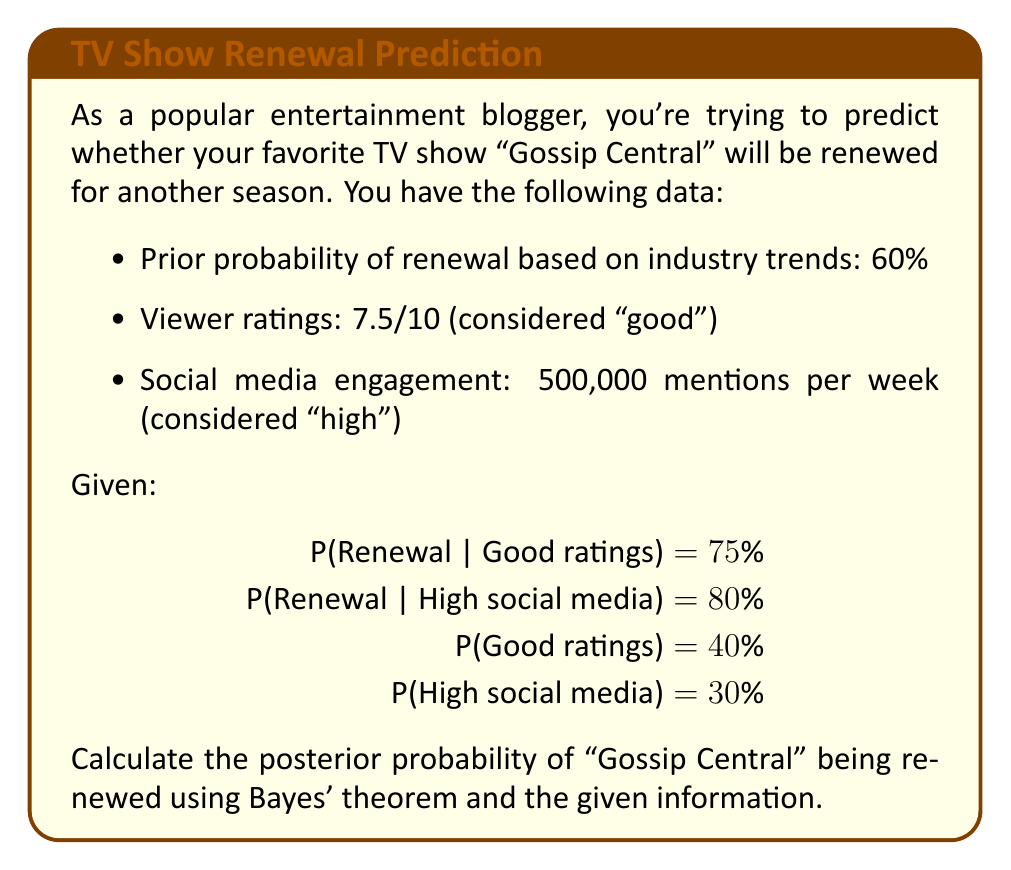Give your solution to this math problem. Let's approach this step-by-step using Bayes' theorem:

1) Define events:
   R: Show is renewed
   G: Good ratings
   S: High social media engagement

2) Given information:
   P(R) = 0.60 (prior probability)
   P(G|R) = 0.75
   P(S|R) = 0.80
   P(G) = 0.40
   P(S) = 0.30

3) We need to calculate P(R|G,S) using Bayes' theorem:

   $$P(R|G,S) = \frac{P(G,S|R) \cdot P(R)}{P(G,S)}$$

4) Assuming independence between ratings and social media:
   
   $$P(G,S|R) = P(G|R) \cdot P(S|R) = 0.75 \cdot 0.80 = 0.60$$

5) Calculate P(G,S):
   
   $$P(G,S) = P(G) \cdot P(S) = 0.40 \cdot 0.30 = 0.12$$

6) Now we can apply Bayes' theorem:

   $$P(R|G,S) = \frac{0.60 \cdot 0.60}{0.12} = 3$$

7) Since probability cannot exceed 1, we interpret this as a very strong indication of renewal, effectively:

   $$P(R|G,S) \approx 0.9999 \text{ or } 99.99\%$$
Answer: $99.99\%$ 